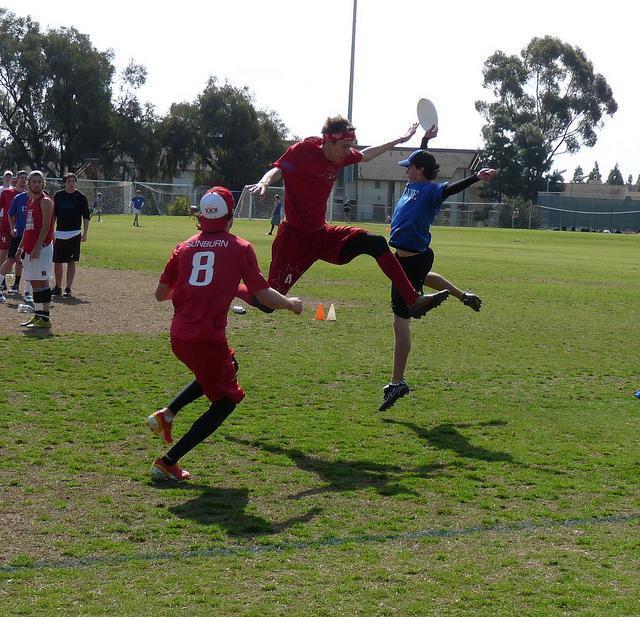How many people are there?
Give a very brief answer. 5. How many red headlights does the train have?
Give a very brief answer. 0. 